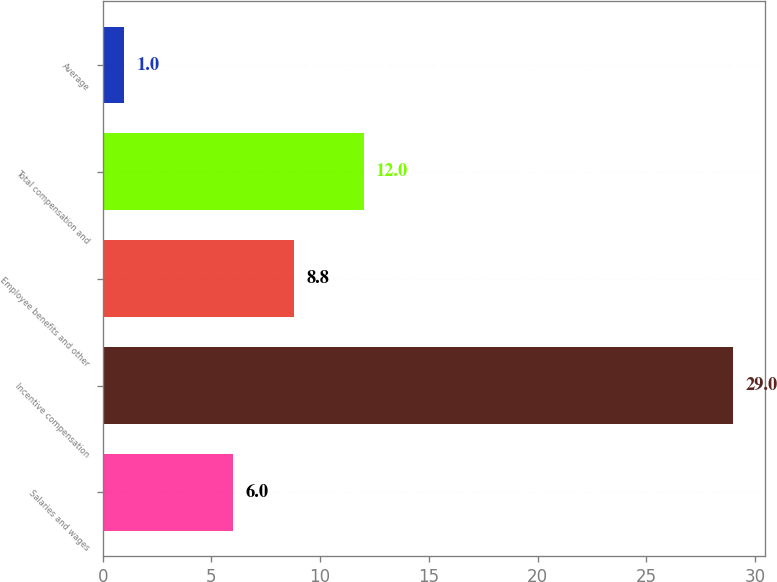<chart> <loc_0><loc_0><loc_500><loc_500><bar_chart><fcel>Salaries and wages<fcel>Incentive compensation<fcel>Employee benefits and other<fcel>Total compensation and<fcel>Average<nl><fcel>6<fcel>29<fcel>8.8<fcel>12<fcel>1<nl></chart> 